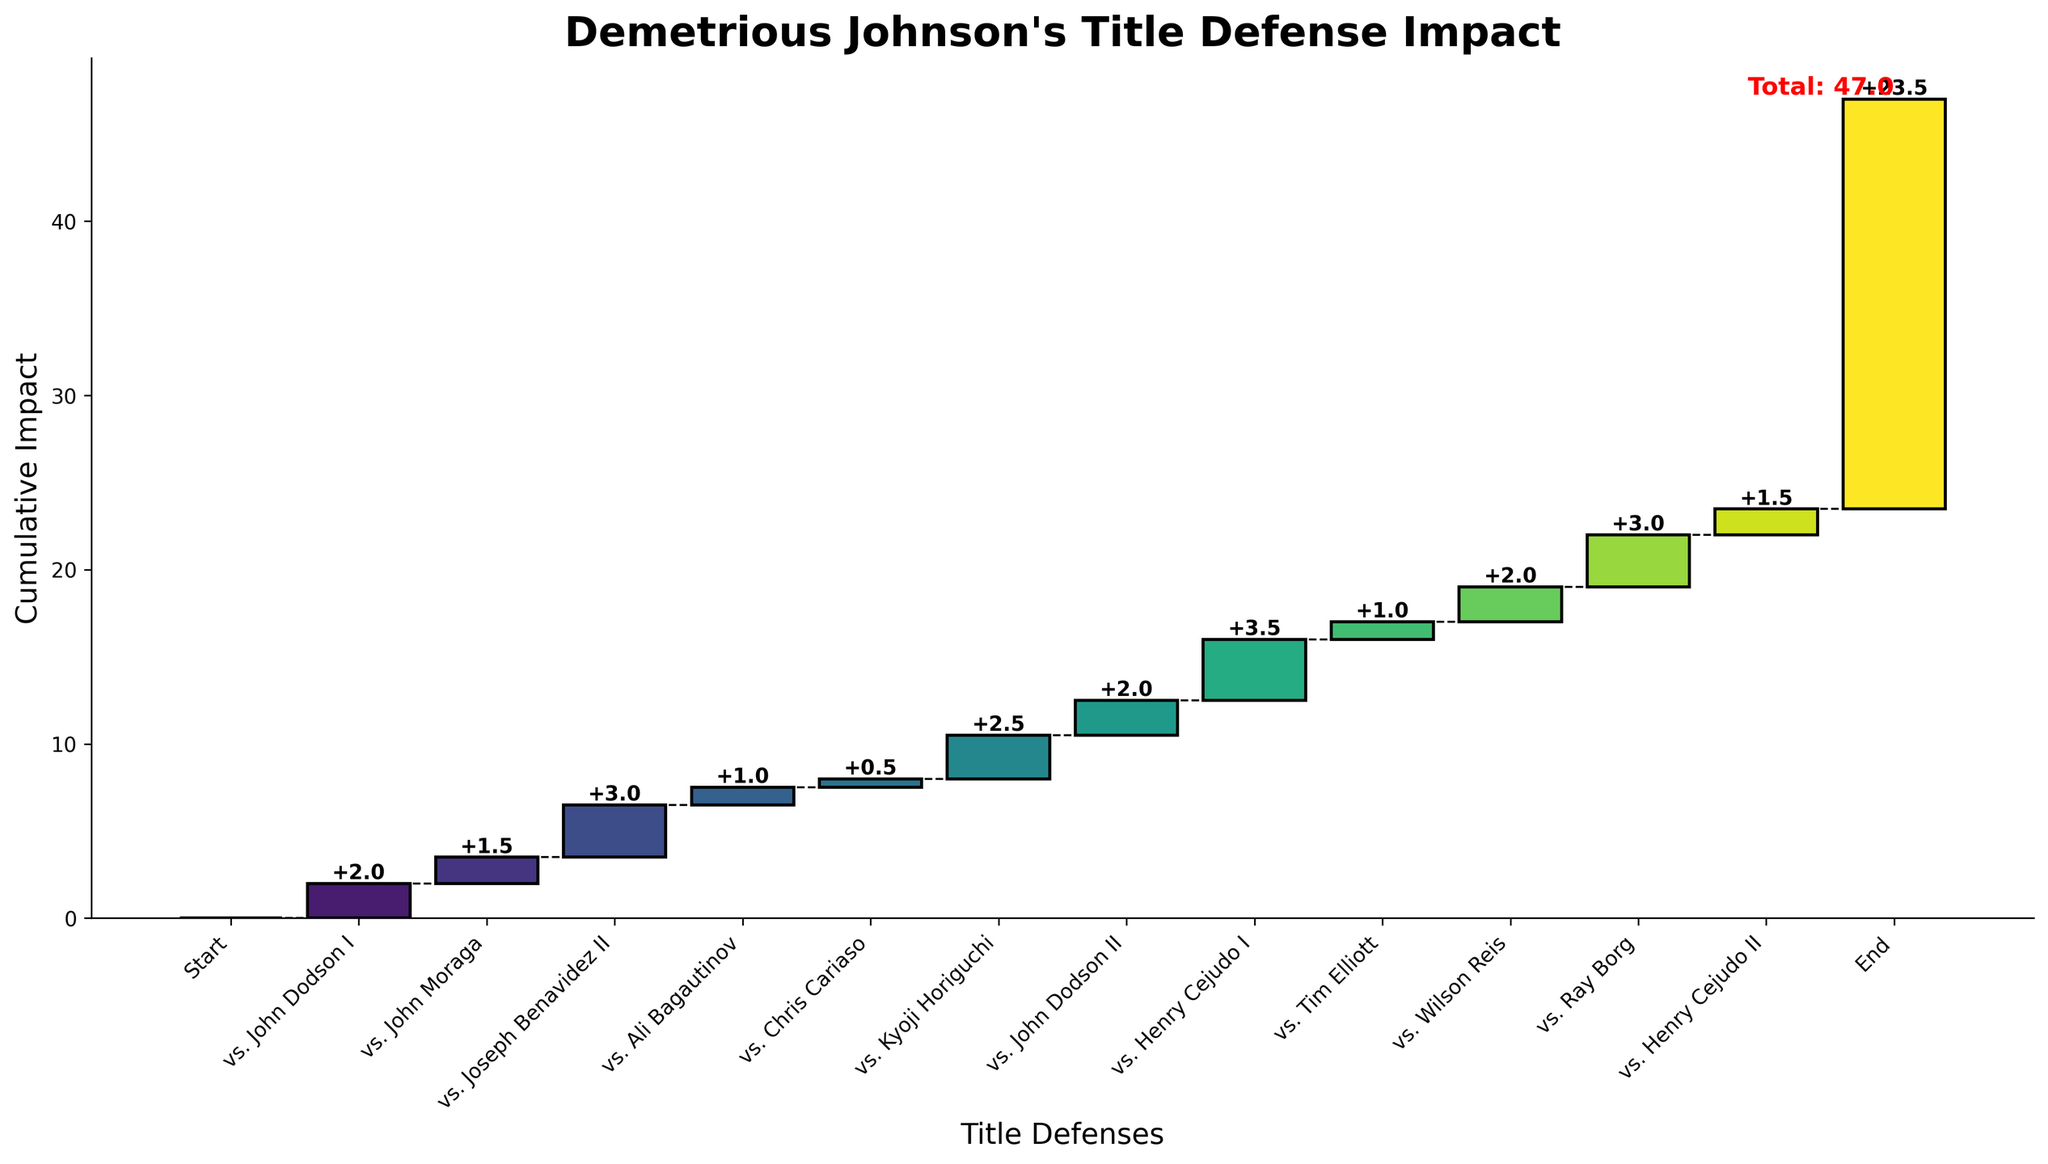How many title defenses did Demetrious Johnson have in total? Count the number of title defenses listed, excluding the start and end points.
Answer: 12 What is the cumulative impact after the fight with Joseph Benavidez II? Look at the chart and note the height of the bar for Joseph Benavidez II. Add the impacts of all preceding fights including this one.
Answer: 6.5 Which title defense had the highest individual impact? Find the title defense name with the highest bar height on the chart and read the corresponding impact value.
Answer: vs. Henry Cejudo I What is the overall cumulative impact by the end of the 12 title defenses? Identify the cumulative impact value at the end of the chart.
Answer: 23.5 How does the impact of Johnson's first title defense compare to his last one? Compare the impact values of the first and last defenses mentioned on the chart.
Answer: First: 2, Last: 1.5 What is the sum of the impacts from the two fights against John Dodson? Add the impact values of the two fights against John Dodson.
Answer: 4 Which defense shows the smallest increase in cumulative impact? Identify the defense with the smallest bar height (positive value) on the chart.
Answer: vs. Chris Cariaso How many title defenses had an impact of 3 or higher? Count the number of title defenses that have bars with heights of 3 or more.
Answer: 4 Between which two consecutive title defenses is the greatest increase in cumulative impact shown? Compare the differences in cumulative impact between each pair of consecutive title defenses and identify the largest.
Answer: vs. Henry Cejudo I and vs. Tim Elliott What is the average impact of all the title defenses? Sum all the individual impacts and divide by the number of title defenses.
Answer: 2 